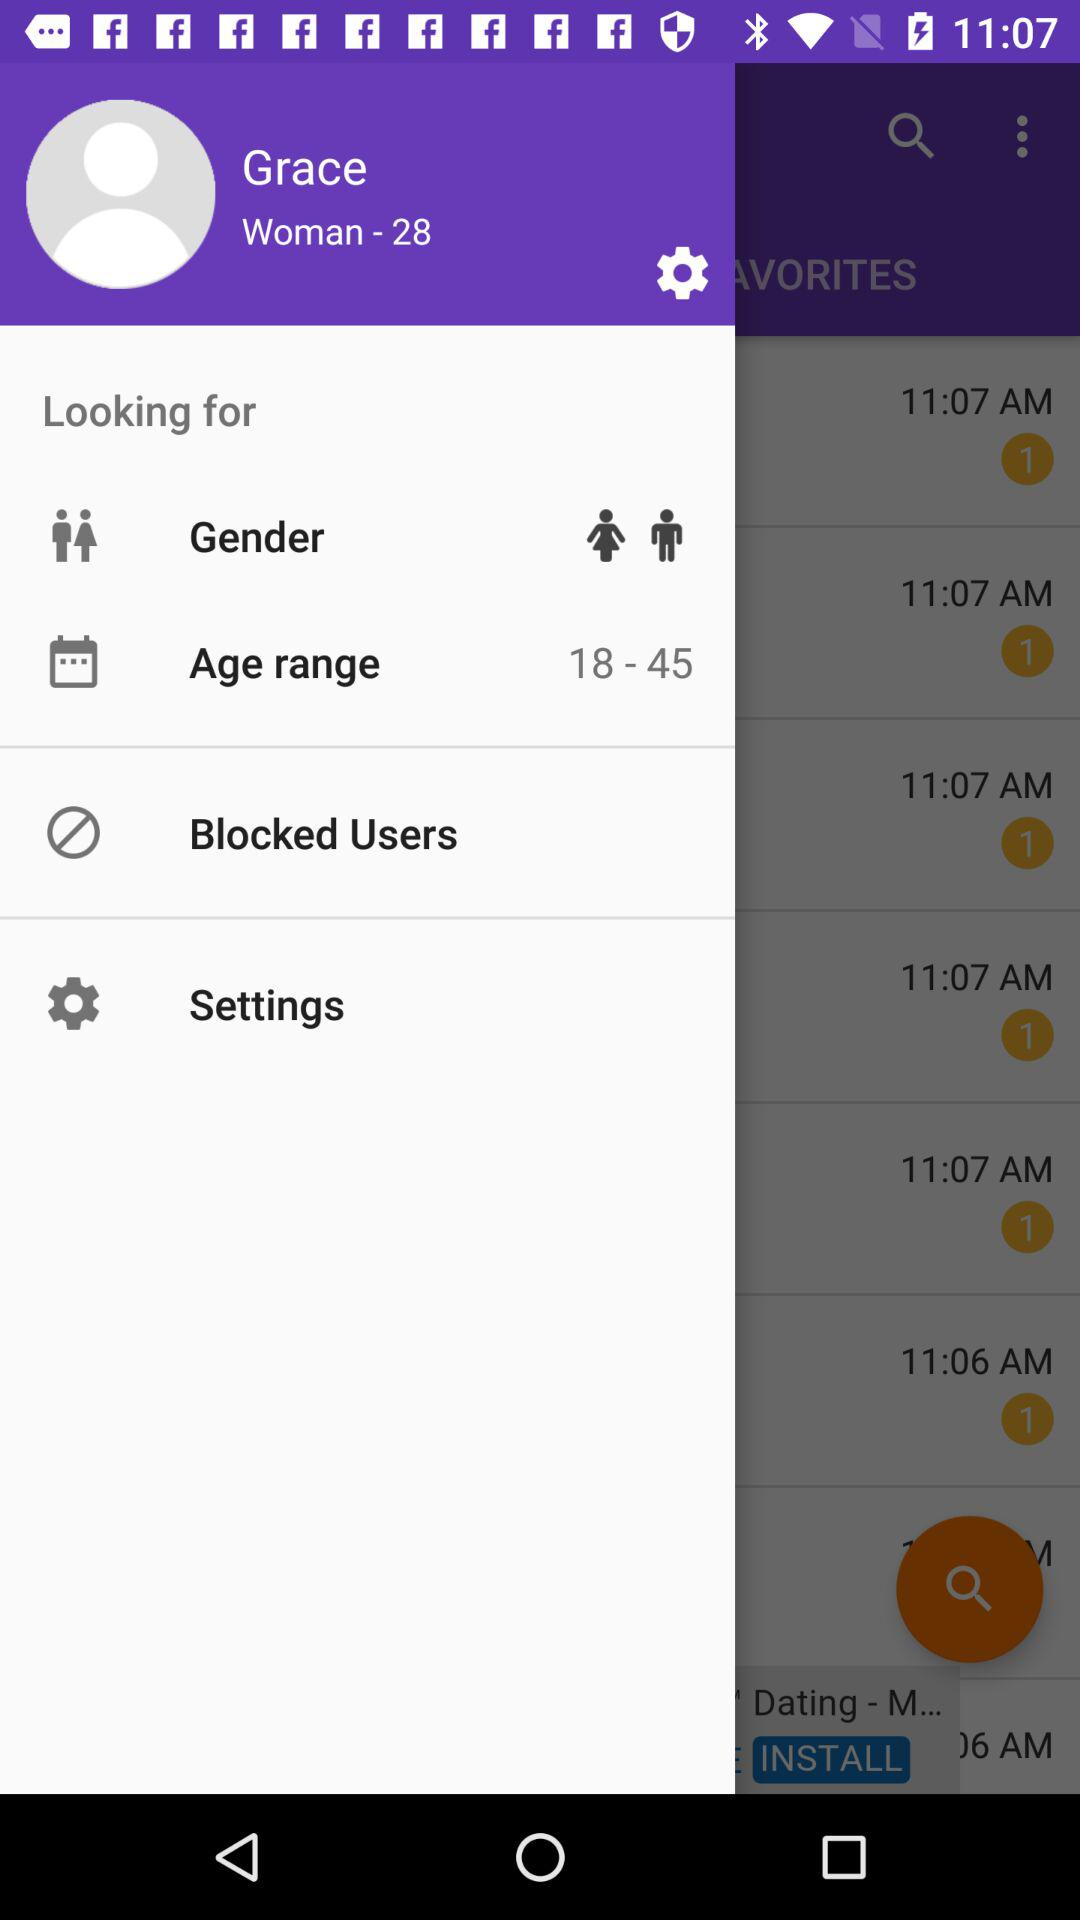What is the age range? The age range is 18 to 45. 